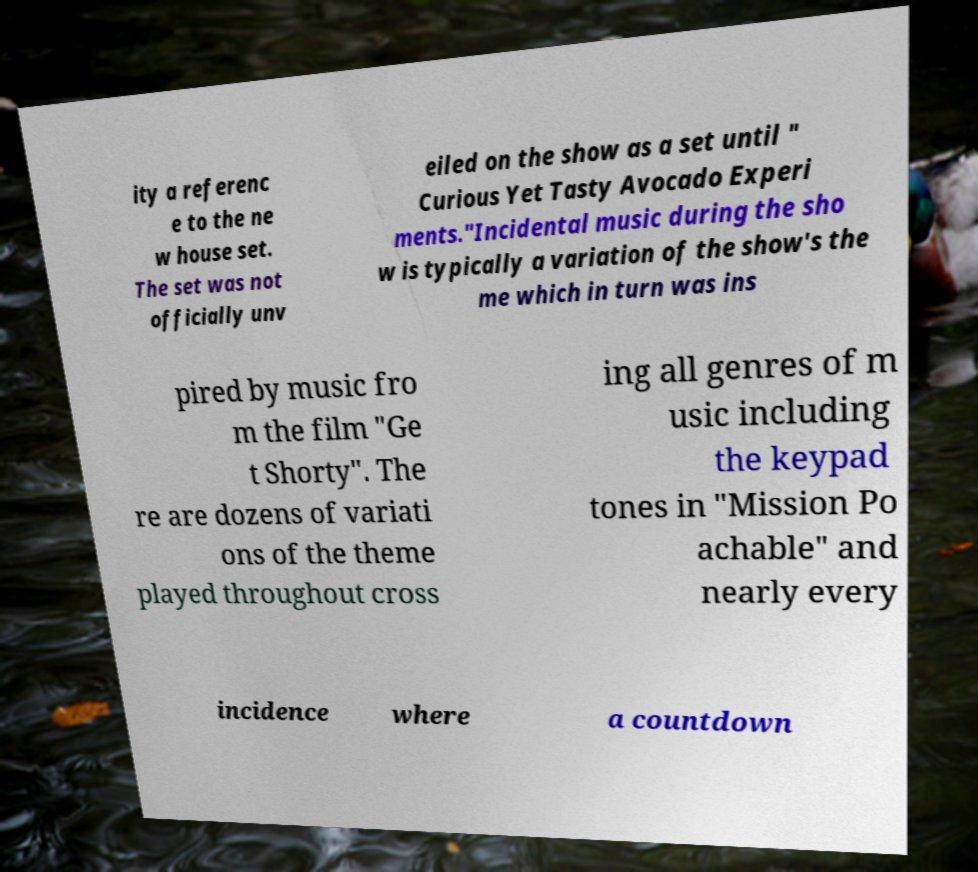Please identify and transcribe the text found in this image. ity a referenc e to the ne w house set. The set was not officially unv eiled on the show as a set until " Curious Yet Tasty Avocado Experi ments."Incidental music during the sho w is typically a variation of the show's the me which in turn was ins pired by music fro m the film "Ge t Shorty". The re are dozens of variati ons of the theme played throughout cross ing all genres of m usic including the keypad tones in "Mission Po achable" and nearly every incidence where a countdown 